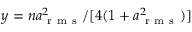<formula> <loc_0><loc_0><loc_500><loc_500>y = n a _ { r m s } ^ { 2 } / [ 4 ( 1 + a _ { r m s } ^ { 2 } ) ]</formula> 